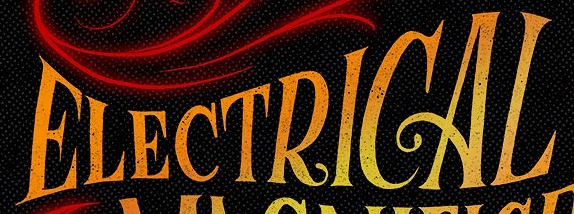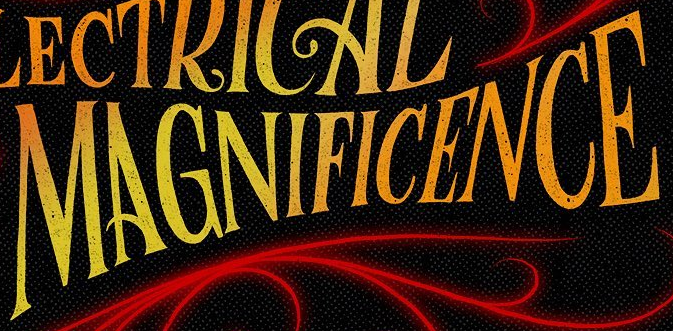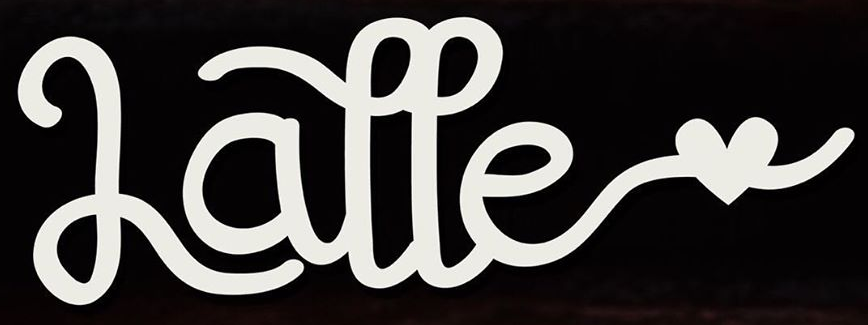Transcribe the words shown in these images in order, separated by a semicolon. ELECTRICAL; MAGNIFICENCE; Latte 